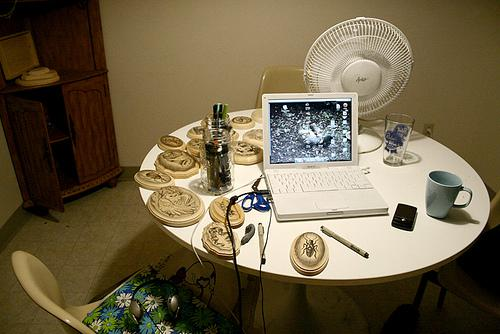Question: where is the laptop?
Choices:
A. Table.
B. The countertop.
C. On the bed.
D. In storage.
Answer with the letter. Answer: A Question: what shape is the table?
Choices:
A. Square.
B. Oval.
C. Triangle.
D. Round.
Answer with the letter. Answer: D Question: where are the headphones?
Choices:
A. Table.
B. Couch.
C. Chair.
D. Drawer.
Answer with the letter. Answer: C 